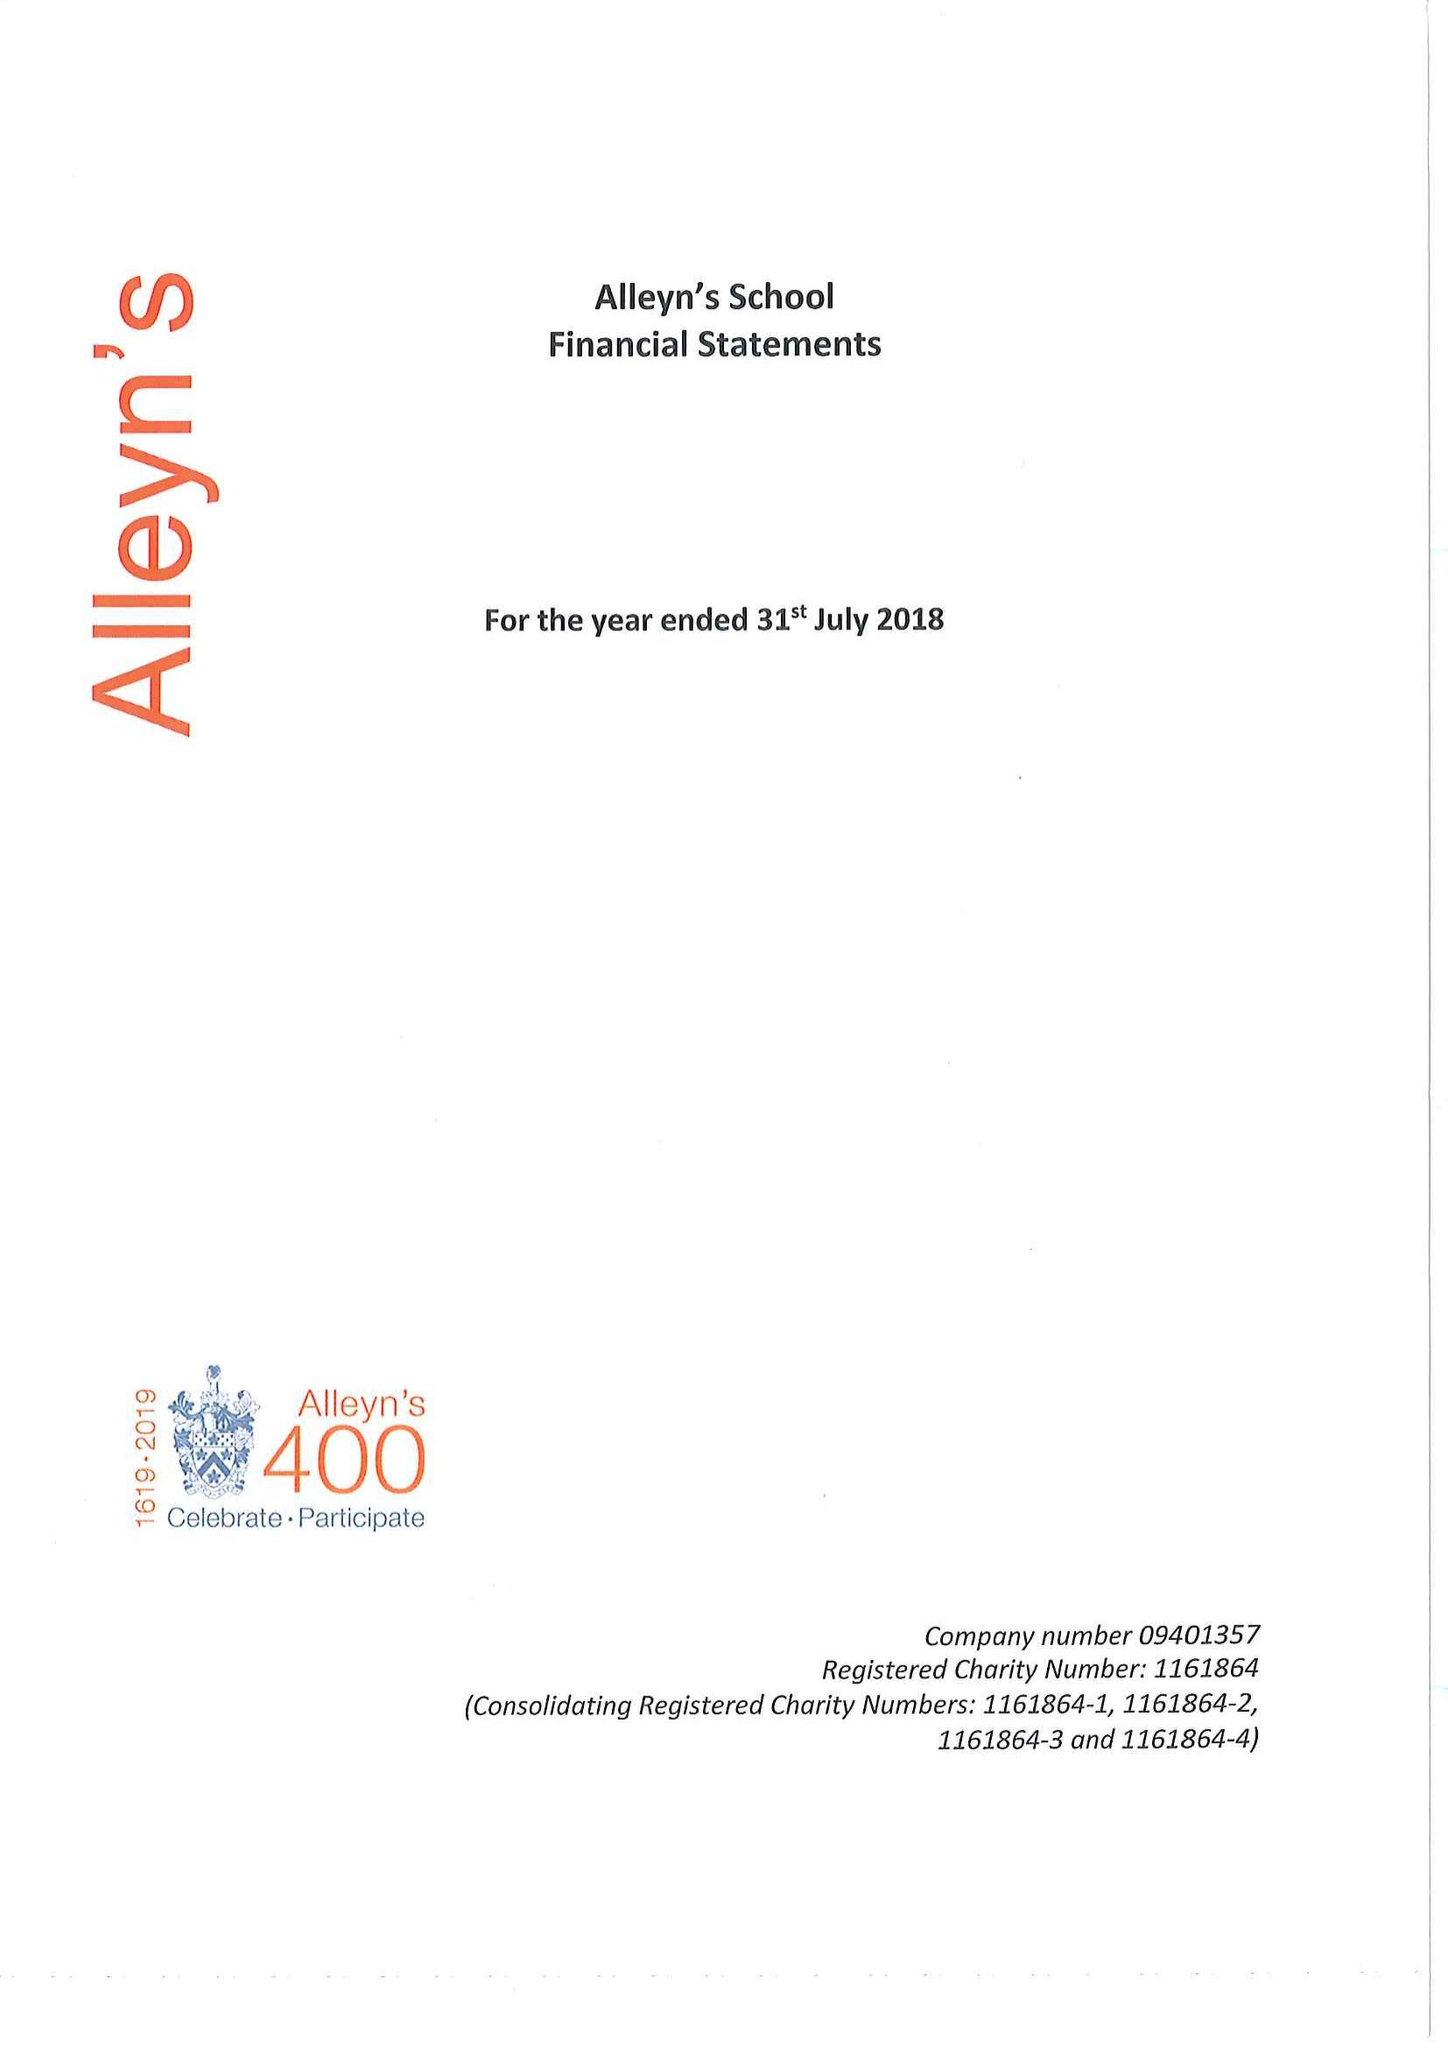What is the value for the address__postcode?
Answer the question using a single word or phrase. SE22 8SU 